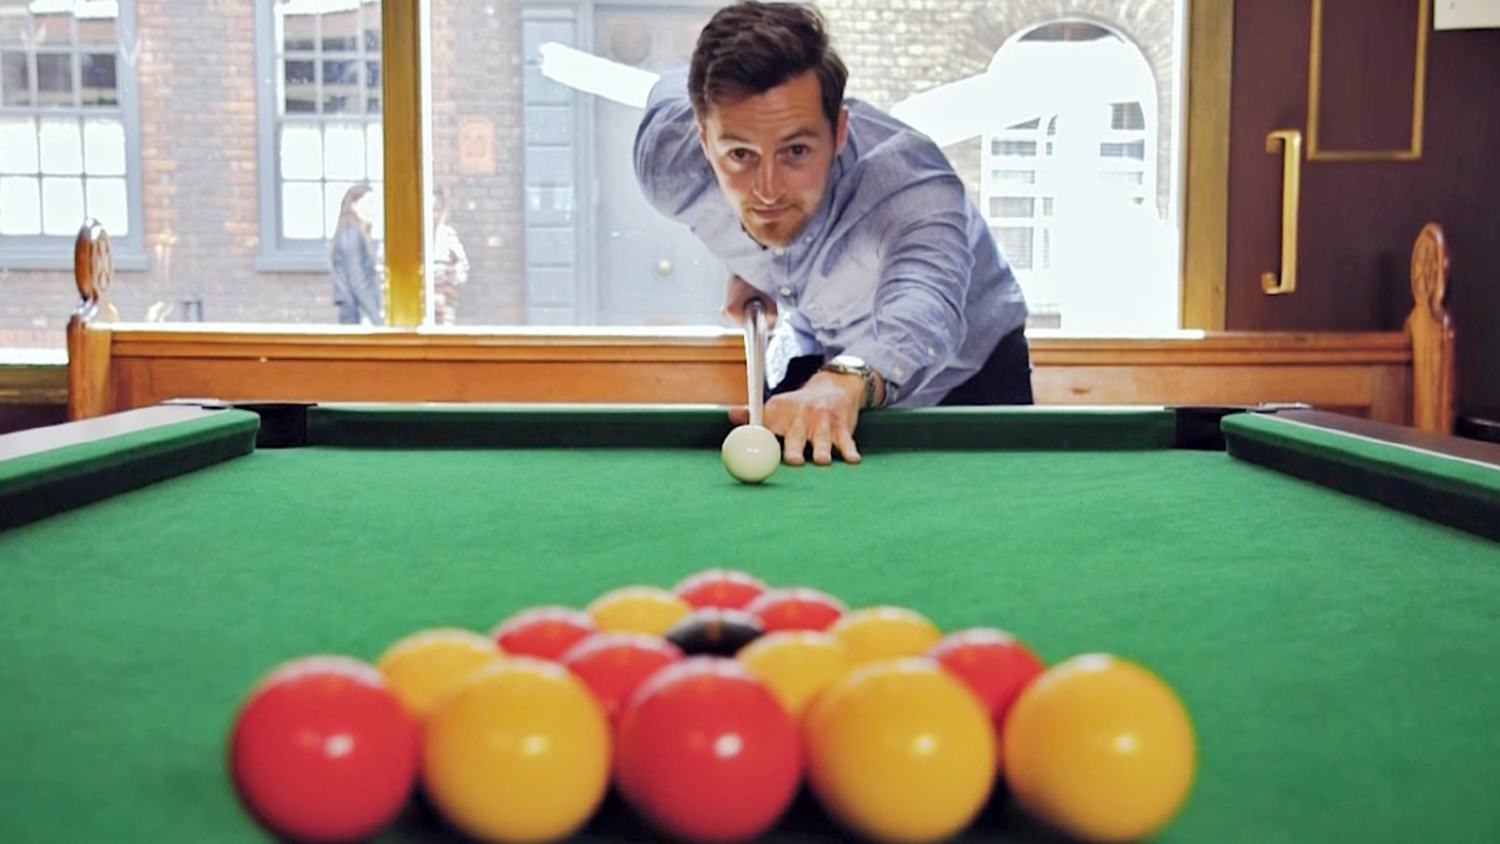What do you think the weather is like outside the pool hall, judging by the window view? Judging by the view through the window, the weather outside appears to be mild and calm. The streets seem dry and there's no indication of rain or snow. The lighting suggests it might be a cloudy day, but not overly dark or gloomy. Could the external environment affect the atmosphere inside the pool hall? Yes, the external environment can influence the atmosphere inside the pool hall. If it's a sunny day, the natural light streaming through the windows can create a bright and cheerful ambiance inside. Conversely, on a gloomy or rainy day, the pool hall might feel more cozy and intimate, making it a perfect spot for people to gather and play indoors. The temperature outside can also affect the hall's temperature, either making it warm and inviting or encouraging people to seek shelter and enjoy a game of pool. 